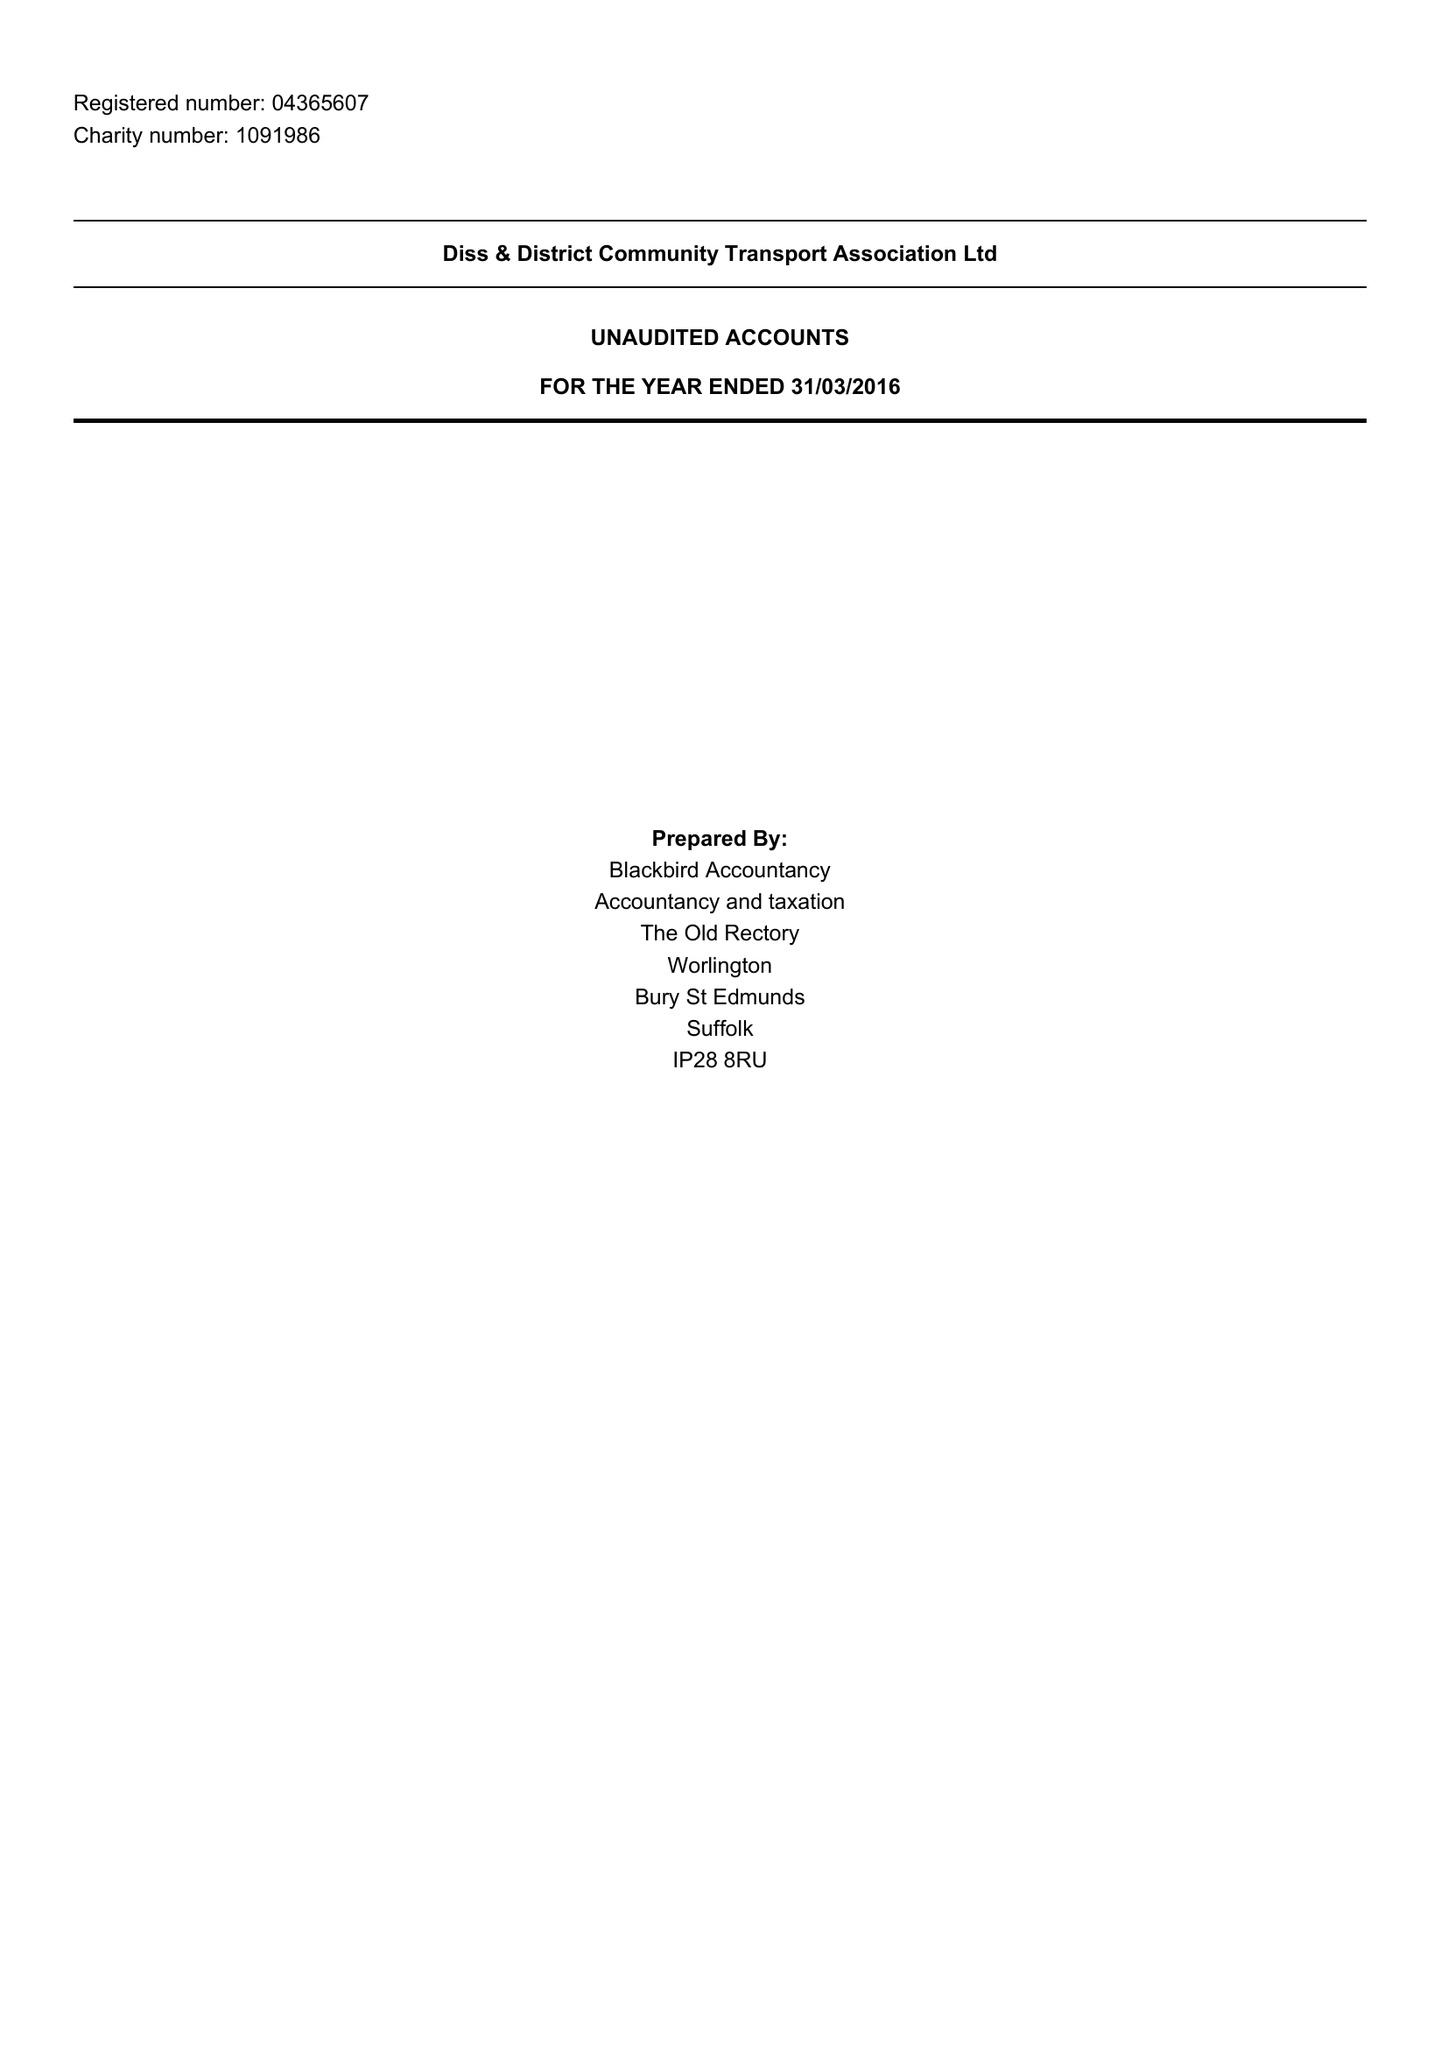What is the value for the address__postcode?
Answer the question using a single word or phrase. IP21 4QD 